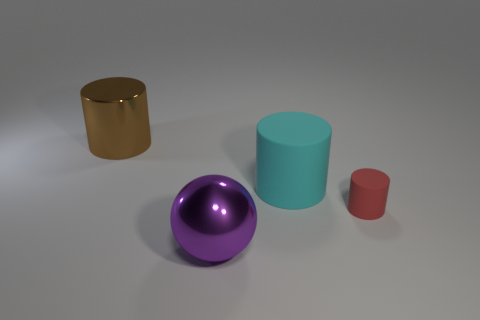Subtract all brown balls. Subtract all cyan cubes. How many balls are left? 1 Add 1 tiny matte cylinders. How many objects exist? 5 Subtract all cylinders. How many objects are left? 1 Add 3 tiny matte things. How many tiny matte things exist? 4 Subtract 0 red cubes. How many objects are left? 4 Subtract all big cyan matte objects. Subtract all big purple things. How many objects are left? 2 Add 4 metal objects. How many metal objects are left? 6 